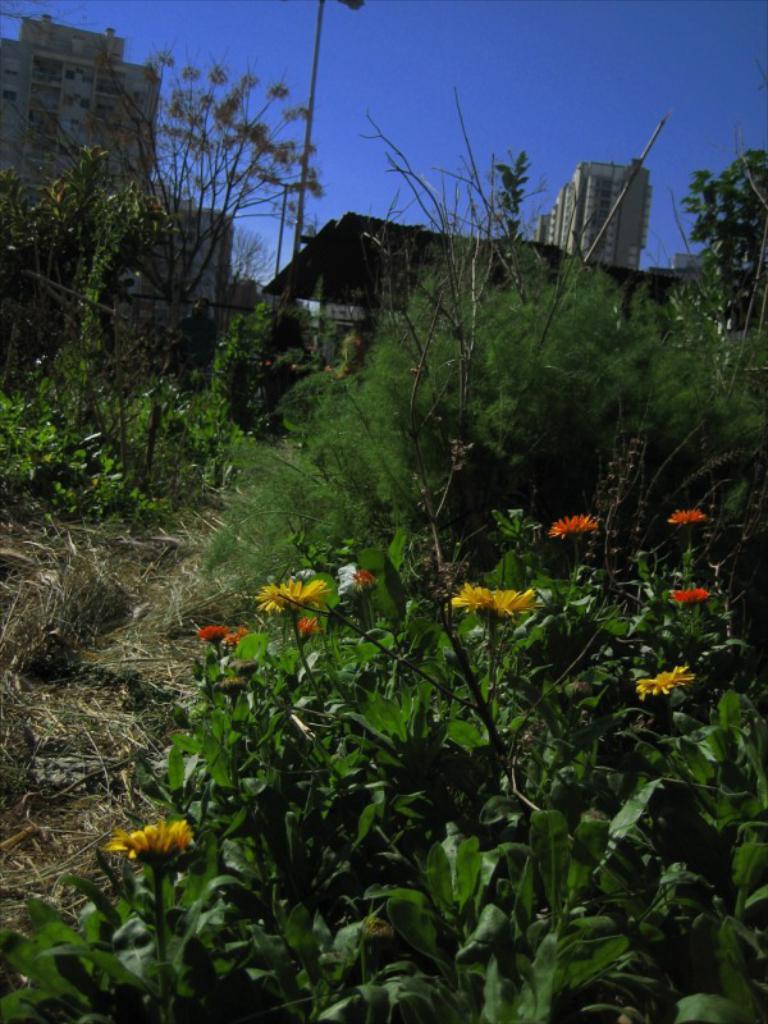Please provide a concise description of this image. In this picture I can see buildings, trees, few plants and flowers. I can see pole light and a blue sky. 